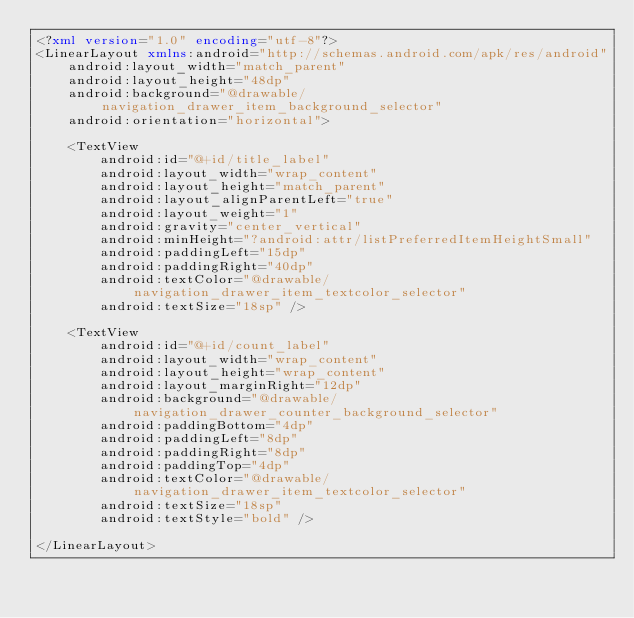<code> <loc_0><loc_0><loc_500><loc_500><_XML_><?xml version="1.0" encoding="utf-8"?>
<LinearLayout xmlns:android="http://schemas.android.com/apk/res/android"
    android:layout_width="match_parent"
    android:layout_height="48dp"
    android:background="@drawable/navigation_drawer_item_background_selector"
    android:orientation="horizontal">

    <TextView
        android:id="@+id/title_label"
        android:layout_width="wrap_content"
        android:layout_height="match_parent"
        android:layout_alignParentLeft="true"
        android:layout_weight="1"
        android:gravity="center_vertical"
        android:minHeight="?android:attr/listPreferredItemHeightSmall"
        android:paddingLeft="15dp"
        android:paddingRight="40dp"
        android:textColor="@drawable/navigation_drawer_item_textcolor_selector"
        android:textSize="18sp" />

    <TextView
        android:id="@+id/count_label"
        android:layout_width="wrap_content"
        android:layout_height="wrap_content"
        android:layout_marginRight="12dp"
        android:background="@drawable/navigation_drawer_counter_background_selector"
        android:paddingBottom="4dp"
        android:paddingLeft="8dp"
        android:paddingRight="8dp"
        android:paddingTop="4dp"
        android:textColor="@drawable/navigation_drawer_item_textcolor_selector"
        android:textSize="18sp"
        android:textStyle="bold" />

</LinearLayout></code> 